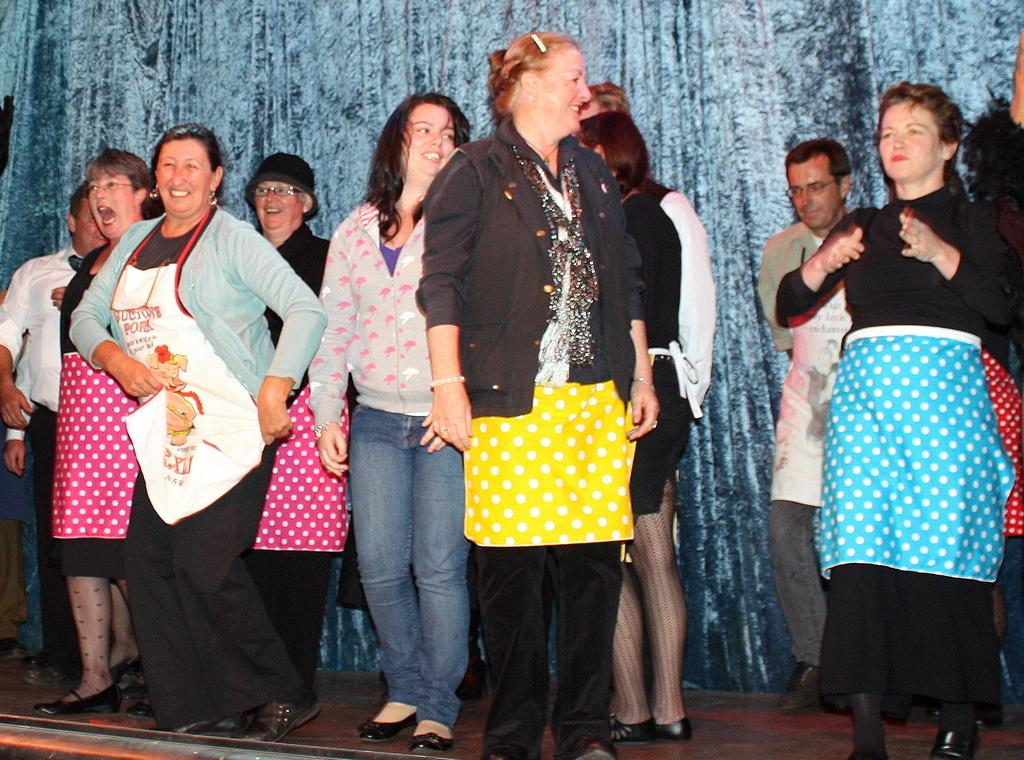Who or what can be seen in the image? There are people in the image. What are the people doing in the image? The people are standing. How do the people appear to be feeling in the image? The people have smiles on their faces, indicating they are happy or enjoying themselves. What else can be seen in the image besides the people? There is a curtain visible in the image. What type of plastic is covering the toad in the image? There is no toad or plastic present in the image. 